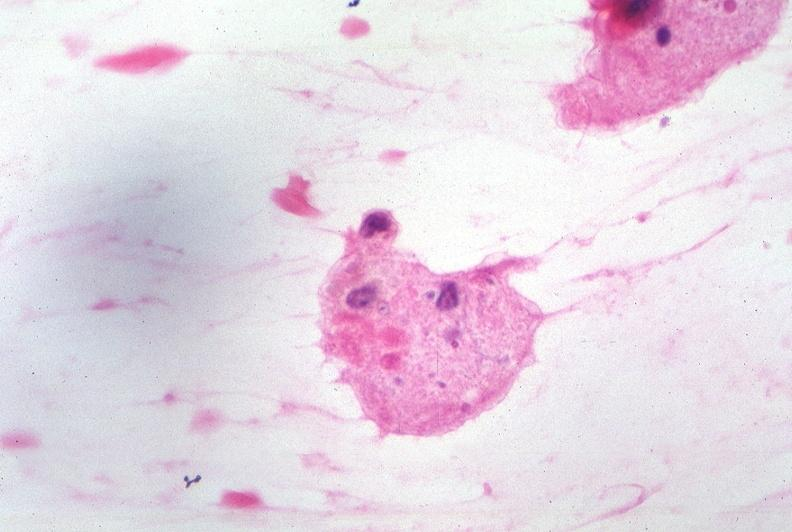does this image show touch impression from cerebrospinal fluid - toxoplasma?
Answer the question using a single word or phrase. Yes 